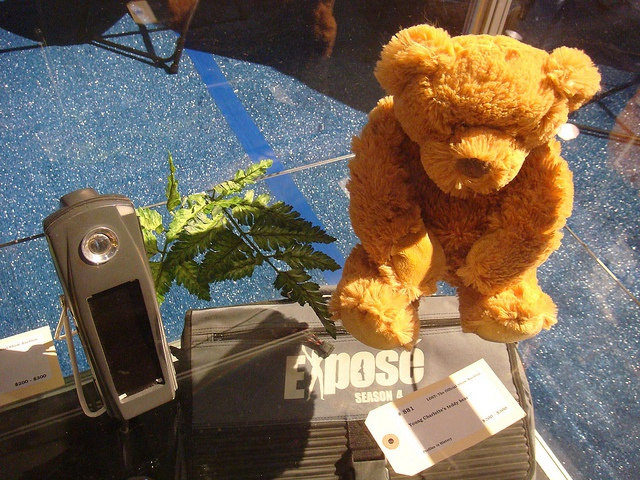Describe the objects in this image and their specific colors. I can see teddy bear in teal, maroon, brown, gold, and orange tones and cell phone in teal, black, and gray tones in this image. 